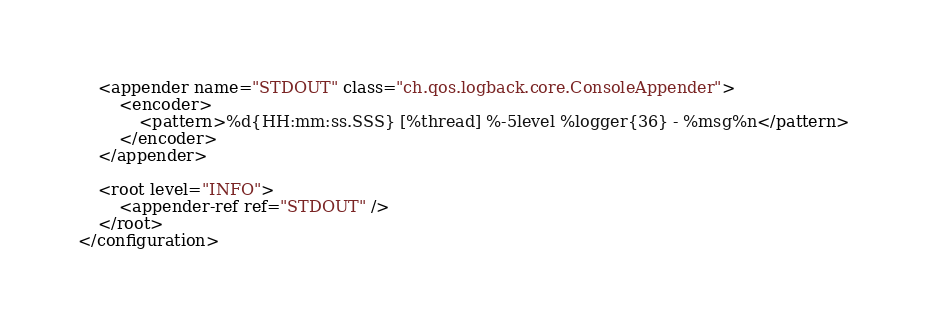Convert code to text. <code><loc_0><loc_0><loc_500><loc_500><_XML_>    <appender name="STDOUT" class="ch.qos.logback.core.ConsoleAppender">
        <encoder>
            <pattern>%d{HH:mm:ss.SSS} [%thread] %-5level %logger{36} - %msg%n</pattern>
        </encoder>
    </appender>

    <root level="INFO">
        <appender-ref ref="STDOUT" />
    </root>
</configuration></code> 